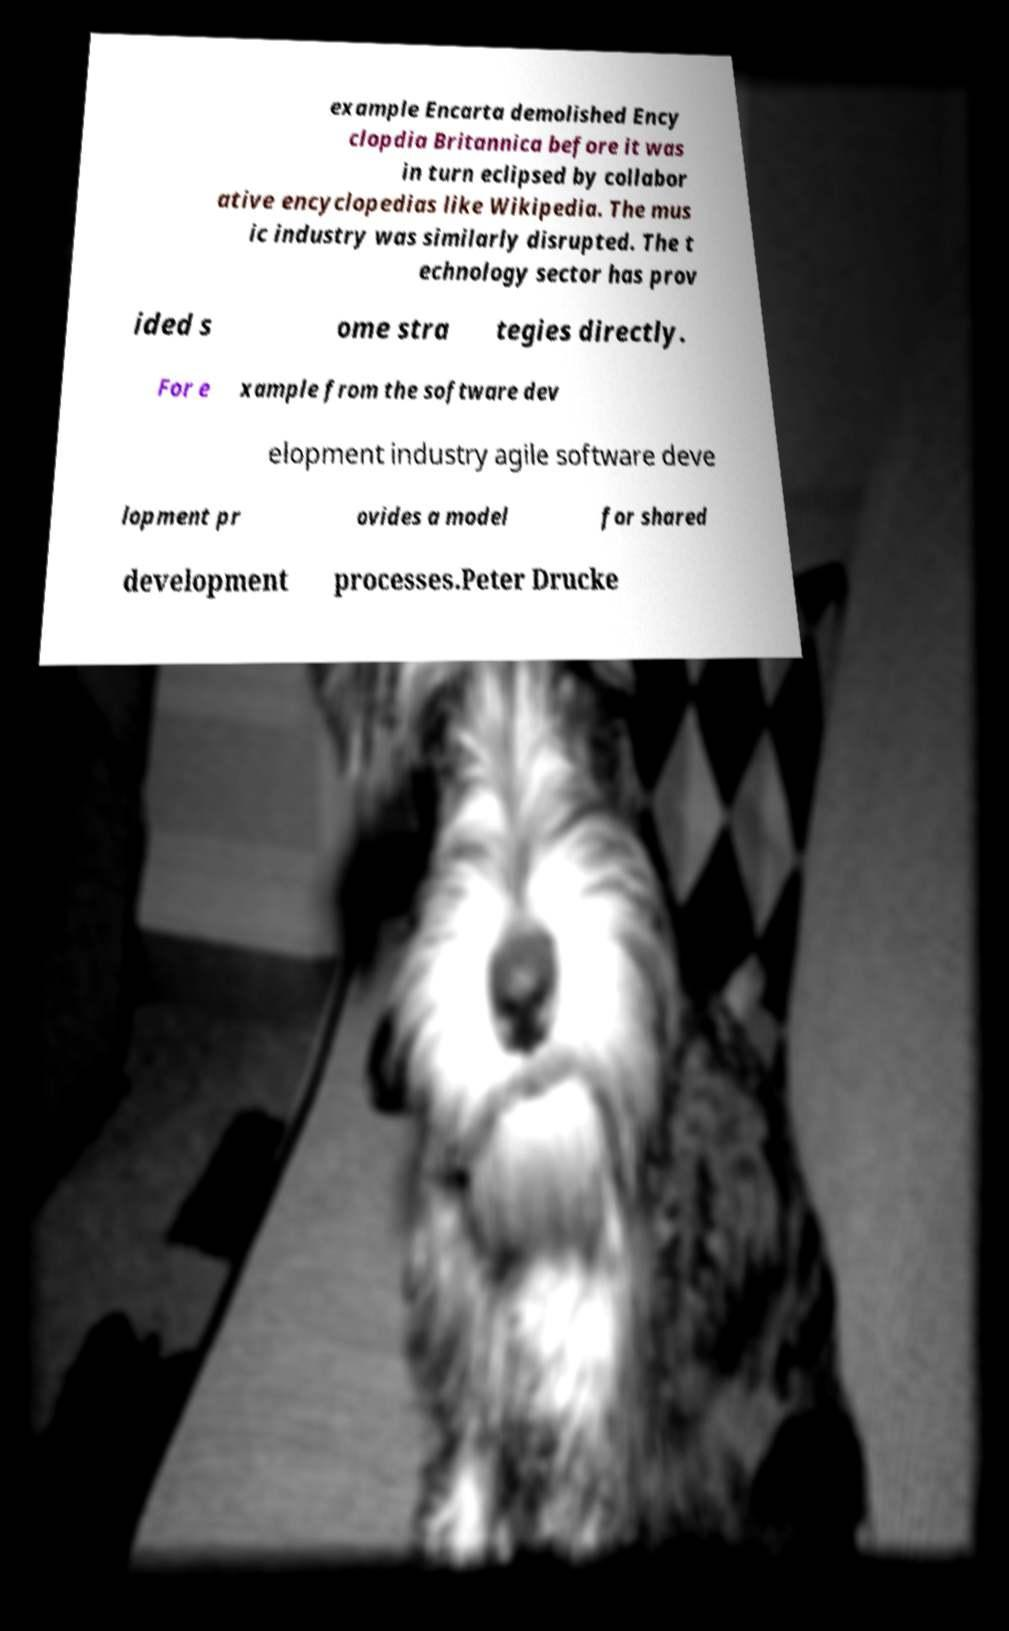Could you assist in decoding the text presented in this image and type it out clearly? example Encarta demolished Ency clopdia Britannica before it was in turn eclipsed by collabor ative encyclopedias like Wikipedia. The mus ic industry was similarly disrupted. The t echnology sector has prov ided s ome stra tegies directly. For e xample from the software dev elopment industry agile software deve lopment pr ovides a model for shared development processes.Peter Drucke 